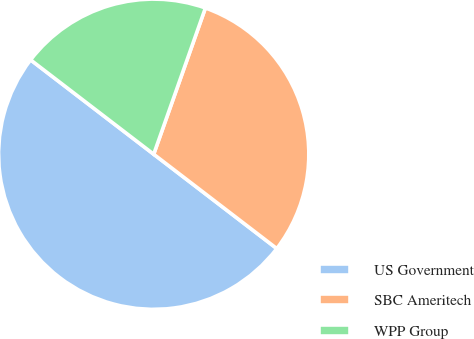<chart> <loc_0><loc_0><loc_500><loc_500><pie_chart><fcel>US Government<fcel>SBC Ameritech<fcel>WPP Group<nl><fcel>50.0%<fcel>30.0%<fcel>20.0%<nl></chart> 